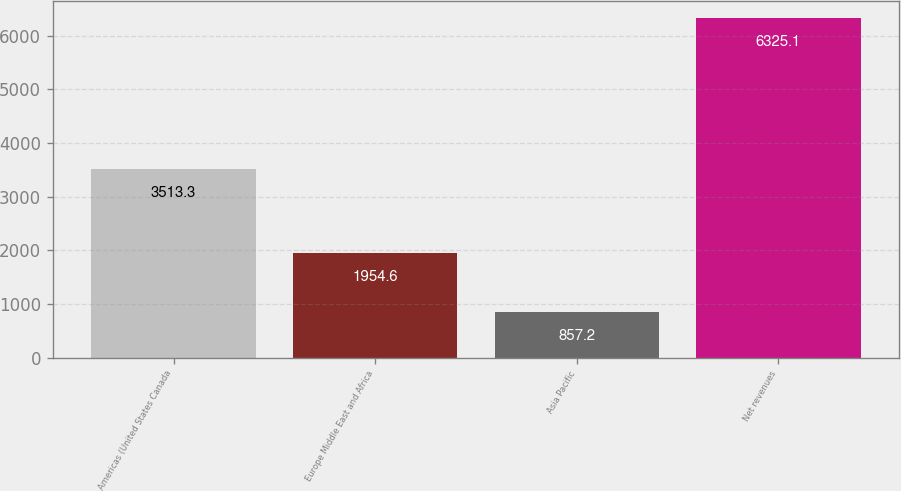Convert chart. <chart><loc_0><loc_0><loc_500><loc_500><bar_chart><fcel>Americas (United States Canada<fcel>Europe Middle East and Africa<fcel>Asia Pacific<fcel>Net revenues<nl><fcel>3513.3<fcel>1954.6<fcel>857.2<fcel>6325.1<nl></chart> 